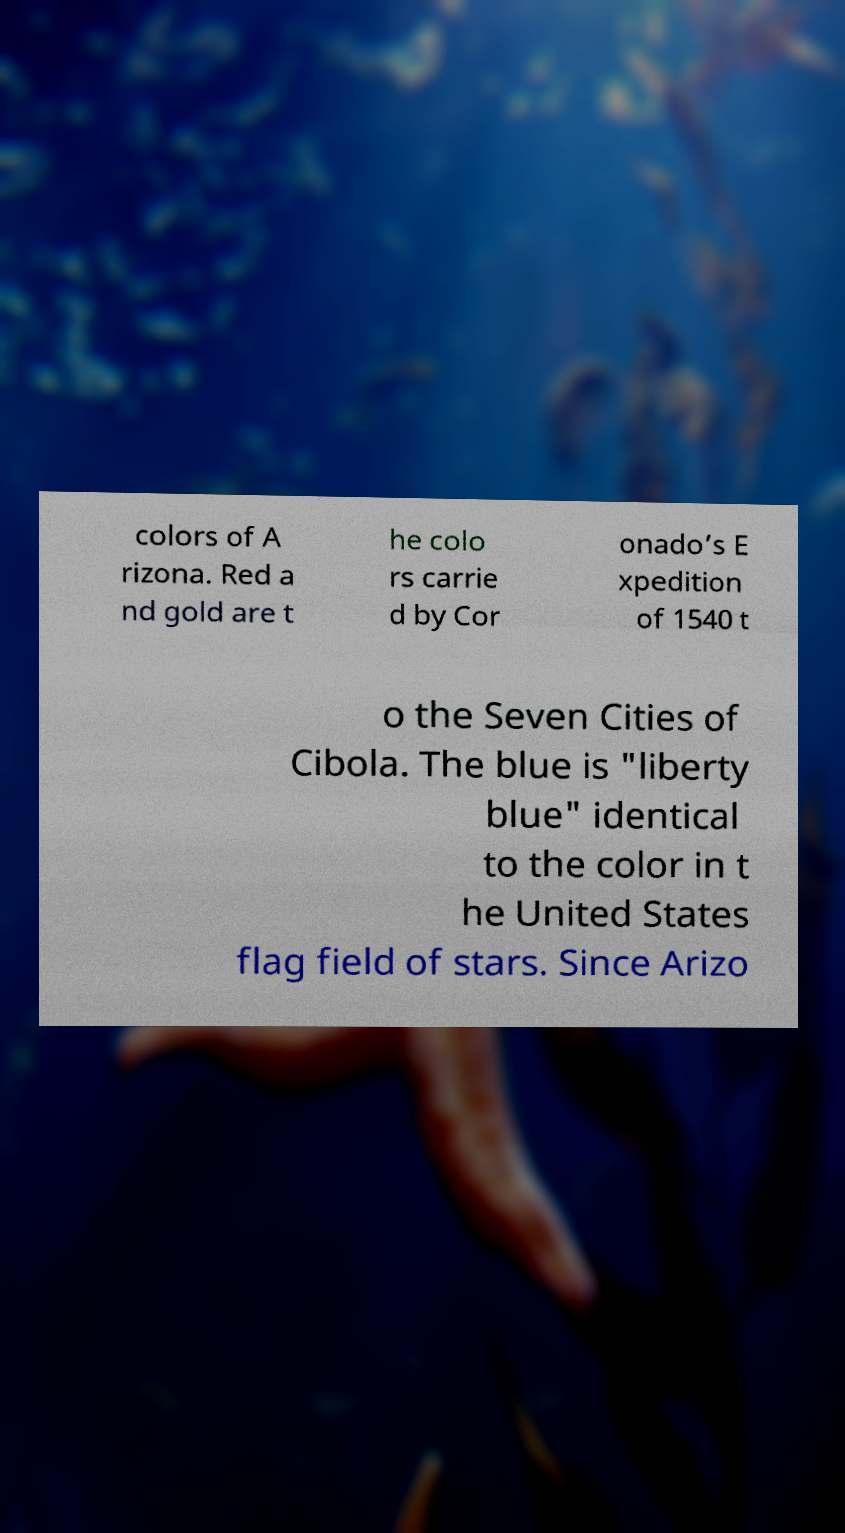Please identify and transcribe the text found in this image. colors of A rizona. Red a nd gold are t he colo rs carrie d by Cor onado’s E xpedition of 1540 t o the Seven Cities of Cibola. The blue is "liberty blue" identical to the color in t he United States flag field of stars. Since Arizo 